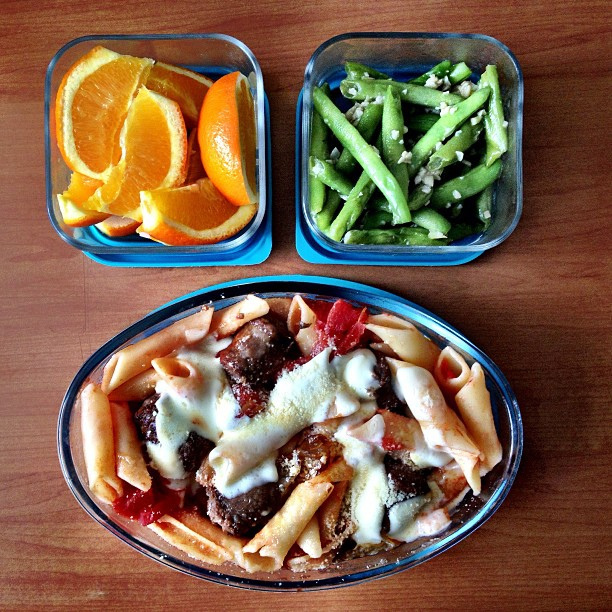What kind of dietary preferences might this meal cater to? This meal appears to cater to a balanced dietary preference, including carbohydrates from the pasta, protein from the meatballs, fiber and vitamins from the green beans, and fruit for a nutritious dessert. However, it's not suitable for vegans or vegetarians due to the meat content. 